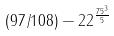<formula> <loc_0><loc_0><loc_500><loc_500>( 9 7 / 1 0 8 ) - 2 2 ^ { \frac { 7 5 ^ { 3 } } { 5 } }</formula> 